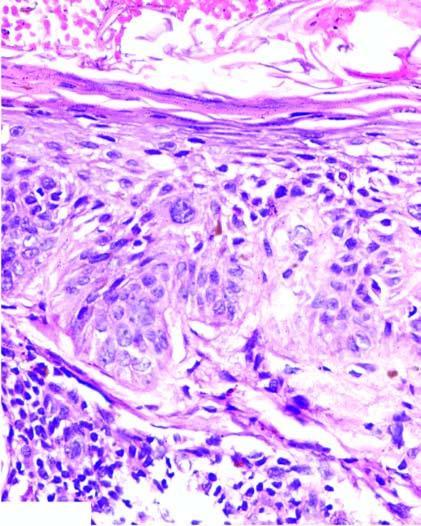s the normal base to surface maturation of epidermal layers effaced?
Answer the question using a single word or phrase. Yes 